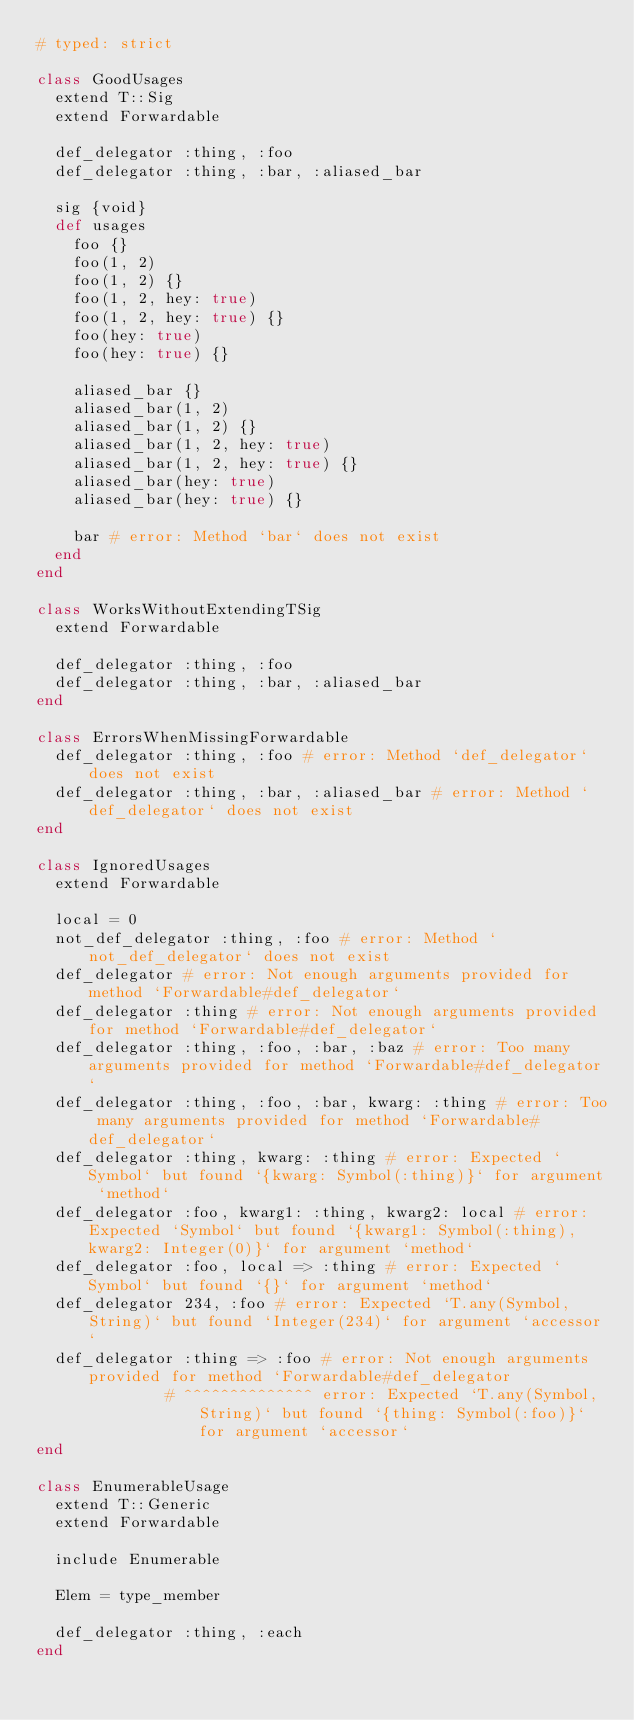<code> <loc_0><loc_0><loc_500><loc_500><_Ruby_># typed: strict

class GoodUsages
  extend T::Sig
  extend Forwardable

  def_delegator :thing, :foo
  def_delegator :thing, :bar, :aliased_bar

  sig {void}
  def usages
    foo {}
    foo(1, 2)
    foo(1, 2) {}
    foo(1, 2, hey: true)
    foo(1, 2, hey: true) {}
    foo(hey: true)
    foo(hey: true) {}

    aliased_bar {}
    aliased_bar(1, 2)
    aliased_bar(1, 2) {}
    aliased_bar(1, 2, hey: true)
    aliased_bar(1, 2, hey: true) {}
    aliased_bar(hey: true)
    aliased_bar(hey: true) {}

    bar # error: Method `bar` does not exist
  end
end

class WorksWithoutExtendingTSig
  extend Forwardable

  def_delegator :thing, :foo
  def_delegator :thing, :bar, :aliased_bar
end

class ErrorsWhenMissingForwardable
  def_delegator :thing, :foo # error: Method `def_delegator` does not exist
  def_delegator :thing, :bar, :aliased_bar # error: Method `def_delegator` does not exist
end

class IgnoredUsages
  extend Forwardable

  local = 0
  not_def_delegator :thing, :foo # error: Method `not_def_delegator` does not exist
  def_delegator # error: Not enough arguments provided for method `Forwardable#def_delegator`
  def_delegator :thing # error: Not enough arguments provided for method `Forwardable#def_delegator`
  def_delegator :thing, :foo, :bar, :baz # error: Too many arguments provided for method `Forwardable#def_delegator`
  def_delegator :thing, :foo, :bar, kwarg: :thing # error: Too many arguments provided for method `Forwardable#def_delegator`
  def_delegator :thing, kwarg: :thing # error: Expected `Symbol` but found `{kwarg: Symbol(:thing)}` for argument `method`
  def_delegator :foo, kwarg1: :thing, kwarg2: local # error: Expected `Symbol` but found `{kwarg1: Symbol(:thing), kwarg2: Integer(0)}` for argument `method`
  def_delegator :foo, local => :thing # error: Expected `Symbol` but found `{}` for argument `method`
  def_delegator 234, :foo # error: Expected `T.any(Symbol, String)` but found `Integer(234)` for argument `accessor`
  def_delegator :thing => :foo # error: Not enough arguments provided for method `Forwardable#def_delegator
              # ^^^^^^^^^^^^^^ error: Expected `T.any(Symbol, String)` but found `{thing: Symbol(:foo)}` for argument `accessor`
end

class EnumerableUsage
  extend T::Generic
  extend Forwardable

  include Enumerable

  Elem = type_member

  def_delegator :thing, :each
end
</code> 